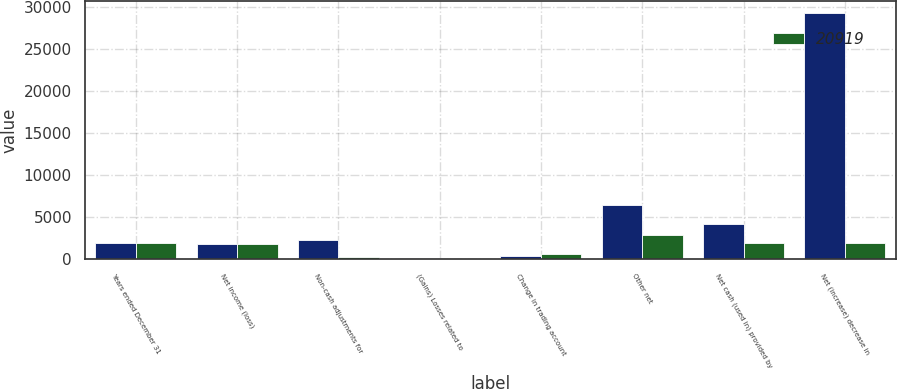Convert chart. <chart><loc_0><loc_0><loc_500><loc_500><stacked_bar_chart><ecel><fcel>Years ended December 31<fcel>Net income (loss)<fcel>Non-cash adjustments for<fcel>(Gains) Losses related to<fcel>Change in trading account<fcel>Other net<fcel>Net cash (used in) provided by<fcel>Net (increase) decrease in<nl><fcel>nan<fcel>2009<fcel>1881<fcel>2284<fcel>141<fcel>366<fcel>6425<fcel>4269<fcel>29222<nl><fcel>20919<fcel>2008<fcel>1811<fcel>282<fcel>54<fcel>689<fcel>2850<fcel>1956<fcel>1956<nl></chart> 